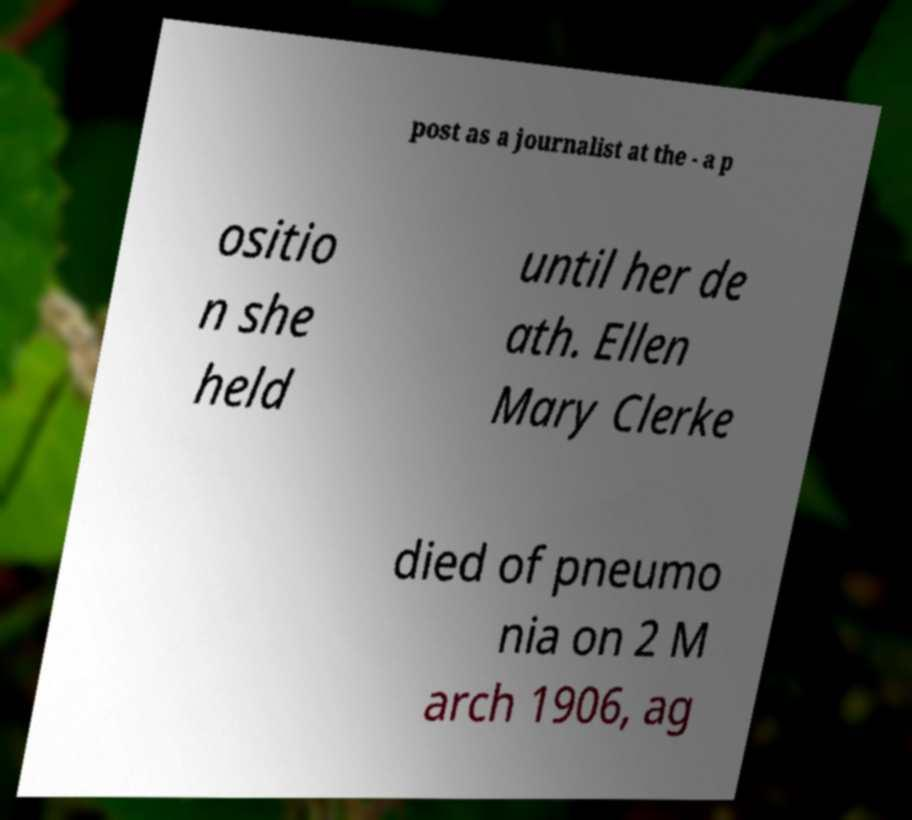What messages or text are displayed in this image? I need them in a readable, typed format. post as a journalist at the - a p ositio n she held until her de ath. Ellen Mary Clerke died of pneumo nia on 2 M arch 1906, ag 